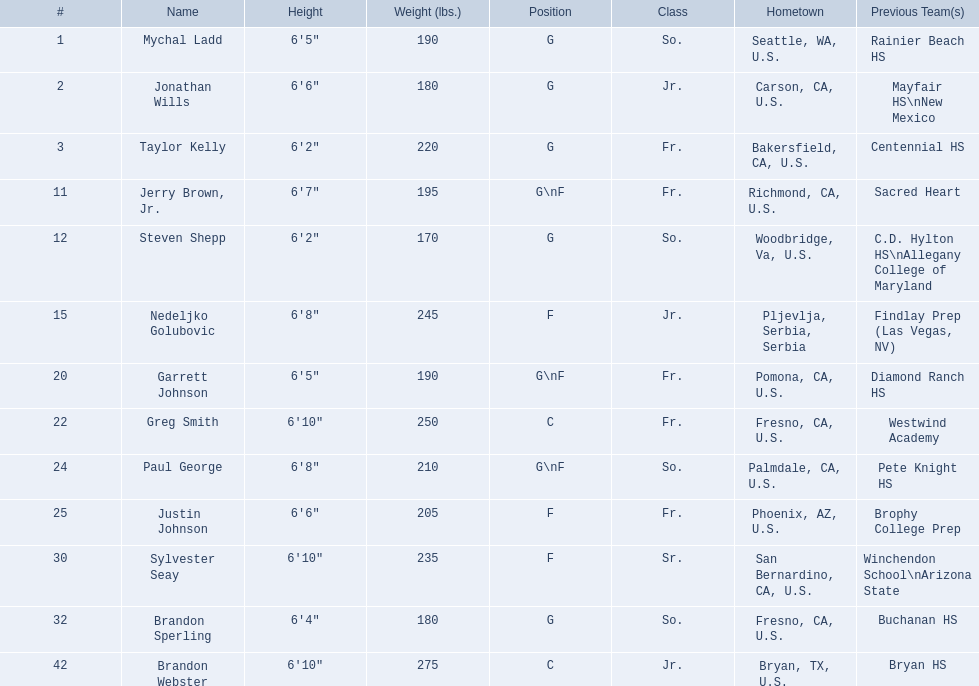Which roles are being referred to? G, G, G\nF, G. What are the weights in grams? 190, 170, 180. Which height is less than 6 feet 3 inches? 6'2". What's the name? Steven Shepp. 